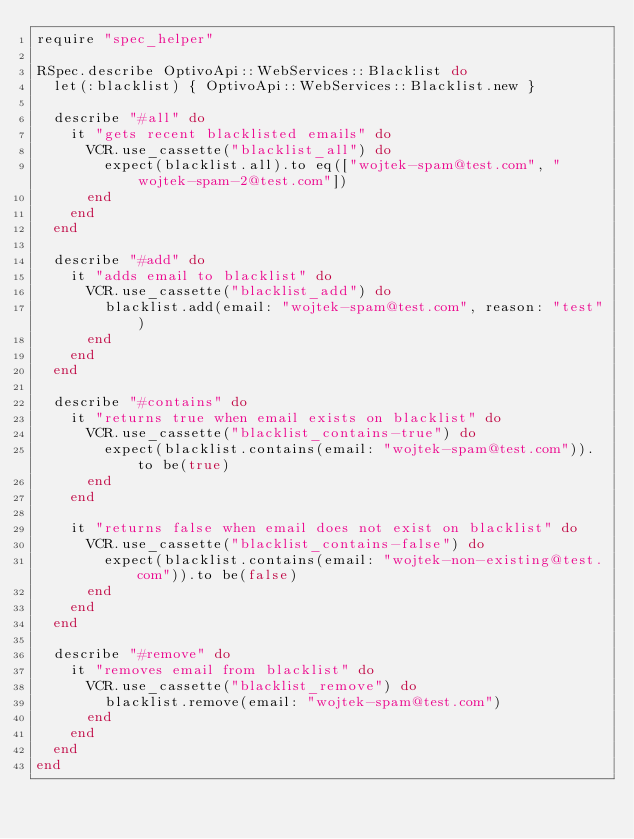Convert code to text. <code><loc_0><loc_0><loc_500><loc_500><_Ruby_>require "spec_helper"

RSpec.describe OptivoApi::WebServices::Blacklist do
  let(:blacklist) { OptivoApi::WebServices::Blacklist.new }

  describe "#all" do
    it "gets recent blacklisted emails" do
      VCR.use_cassette("blacklist_all") do
        expect(blacklist.all).to eq(["wojtek-spam@test.com", "wojtek-spam-2@test.com"])
      end
    end
  end

  describe "#add" do
    it "adds email to blacklist" do
      VCR.use_cassette("blacklist_add") do
        blacklist.add(email: "wojtek-spam@test.com", reason: "test")
      end
    end
  end

  describe "#contains" do
    it "returns true when email exists on blacklist" do
      VCR.use_cassette("blacklist_contains-true") do
        expect(blacklist.contains(email: "wojtek-spam@test.com")).to be(true)
      end
    end

    it "returns false when email does not exist on blacklist" do
      VCR.use_cassette("blacklist_contains-false") do
        expect(blacklist.contains(email: "wojtek-non-existing@test.com")).to be(false)
      end
    end
  end

  describe "#remove" do
    it "removes email from blacklist" do
      VCR.use_cassette("blacklist_remove") do
        blacklist.remove(email: "wojtek-spam@test.com")
      end
    end
  end
end
</code> 